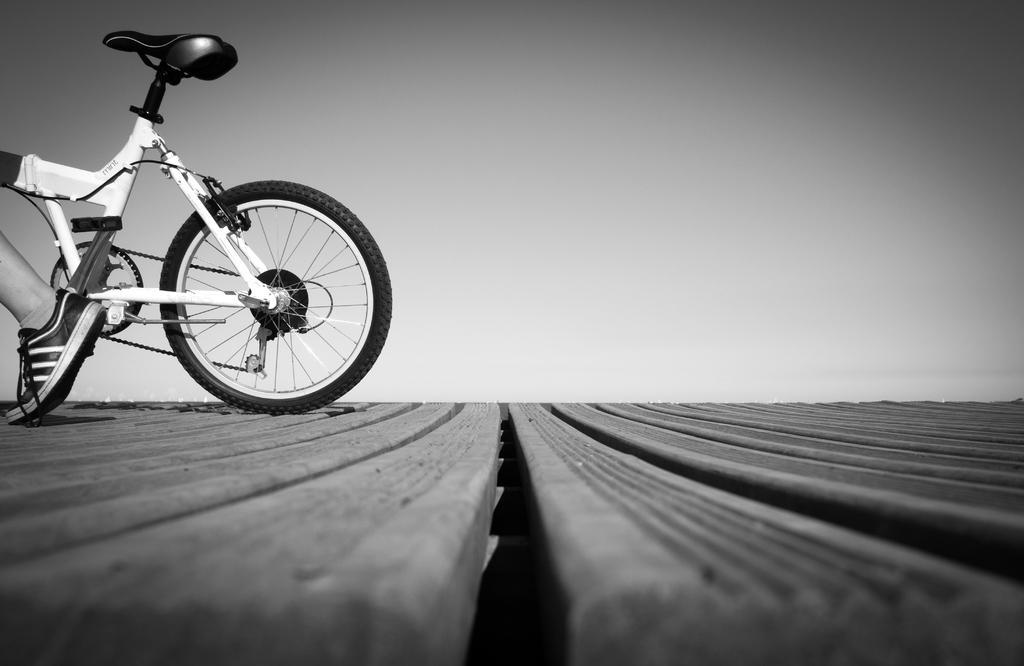In one or two sentences, can you explain what this image depicts? It is a black and white image, there is a wooden surface, on that there is a cycle and there is a leg of a person in front of the cycle. 